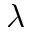<formula> <loc_0><loc_0><loc_500><loc_500>\lambda</formula> 